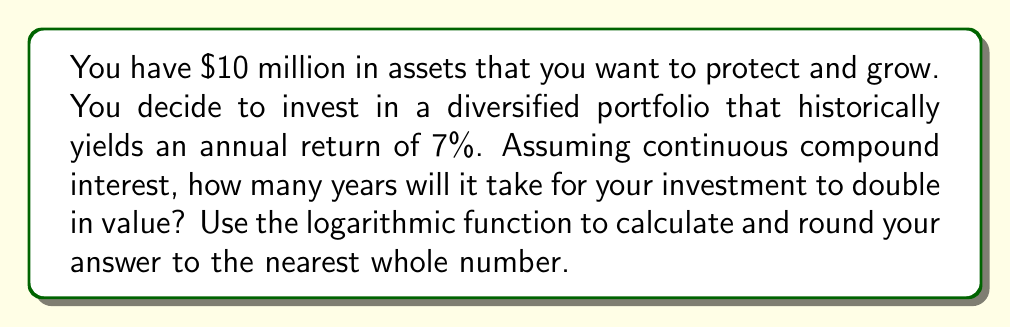What is the answer to this math problem? To solve this problem, we'll use the continuous compound interest formula and the properties of logarithms:

1) The formula for continuous compound interest is:
   $A = P \cdot e^{rt}$
   Where:
   $A$ = final amount
   $P$ = principal (initial investment)
   $r$ = annual interest rate (as a decimal)
   $t$ = time in years
   $e$ = Euler's number (approximately 2.71828)

2) We want to find when the amount doubles, so:
   $2P = P \cdot e^{rt}$

3) Divide both sides by $P$:
   $2 = e^{rt}$

4) Take the natural logarithm of both sides:
   $\ln(2) = \ln(e^{rt})$

5) Using the logarithm property $\ln(e^x) = x$:
   $\ln(2) = rt$

6) Solve for $t$:
   $t = \frac{\ln(2)}{r}$

7) Plug in $r = 0.07$ (7% as a decimal):
   $t = \frac{\ln(2)}{0.07}$

8) Calculate:
   $t \approx 9.9$ years

9) Rounding to the nearest whole number:
   $t = 10$ years
Answer: 10 years 